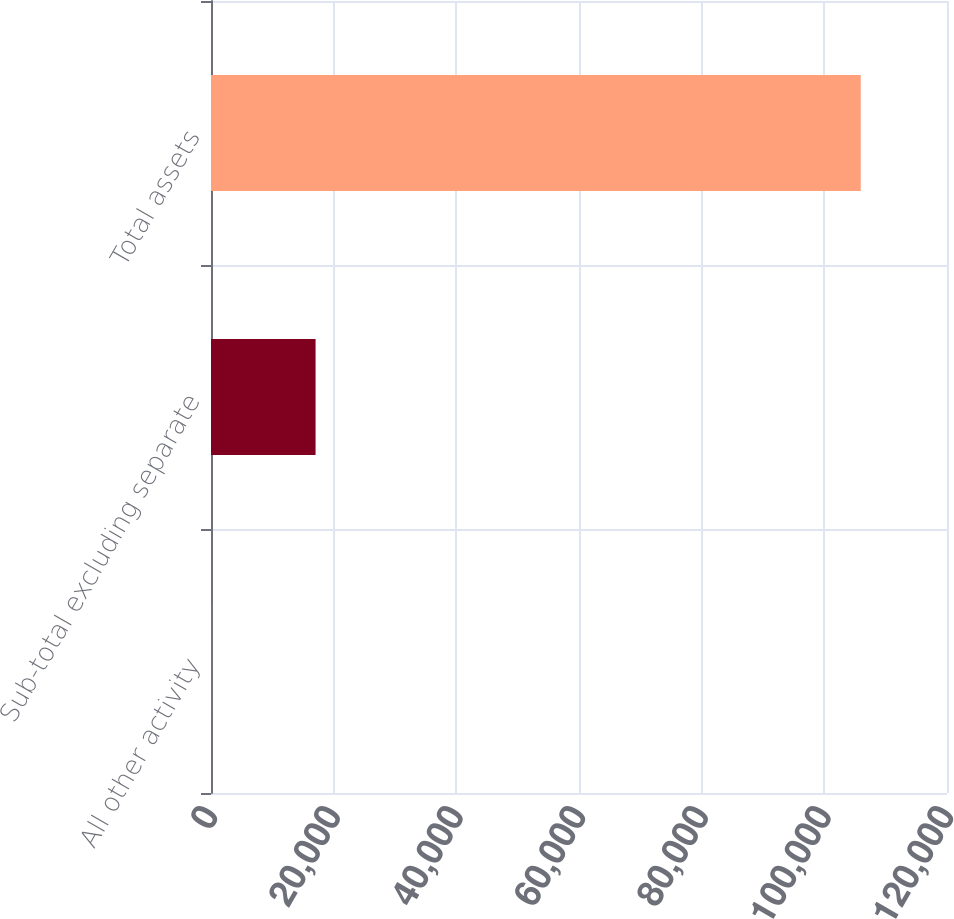<chart> <loc_0><loc_0><loc_500><loc_500><bar_chart><fcel>All other activity<fcel>Sub-total excluding separate<fcel>Total assets<nl><fcel>13<fcel>17049<fcel>105937<nl></chart> 